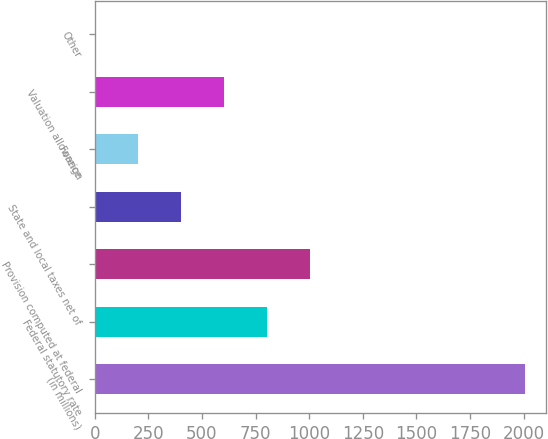Convert chart. <chart><loc_0><loc_0><loc_500><loc_500><bar_chart><fcel>(in millions)<fcel>Federal statutory rate<fcel>Provision computed at federal<fcel>State and local taxes net of<fcel>Foreign<fcel>Valuation allowance<fcel>Other<nl><fcel>2004<fcel>802.14<fcel>1002.45<fcel>401.52<fcel>201.21<fcel>601.83<fcel>0.9<nl></chart> 